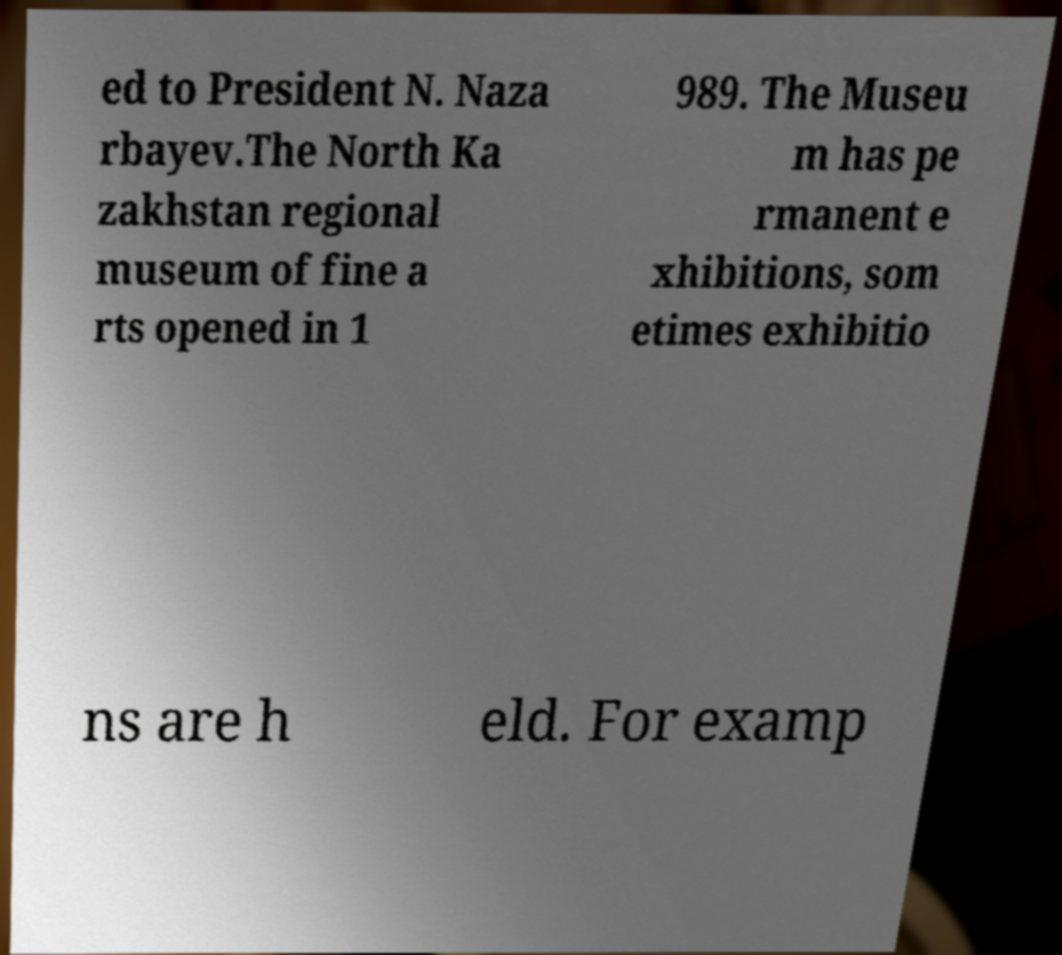Can you read and provide the text displayed in the image?This photo seems to have some interesting text. Can you extract and type it out for me? ed to President N. Naza rbayev.The North Ka zakhstan regional museum of fine a rts opened in 1 989. The Museu m has pe rmanent e xhibitions, som etimes exhibitio ns are h eld. For examp 